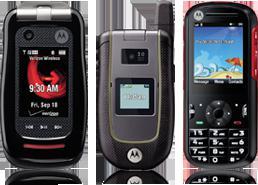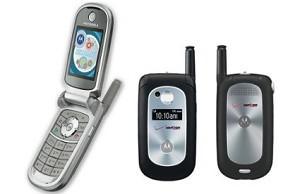The first image is the image on the left, the second image is the image on the right. For the images displayed, is the sentence "In at least one image there are two phones, one that is open and sliver and the other is closed and blue." factually correct? Answer yes or no. No. 